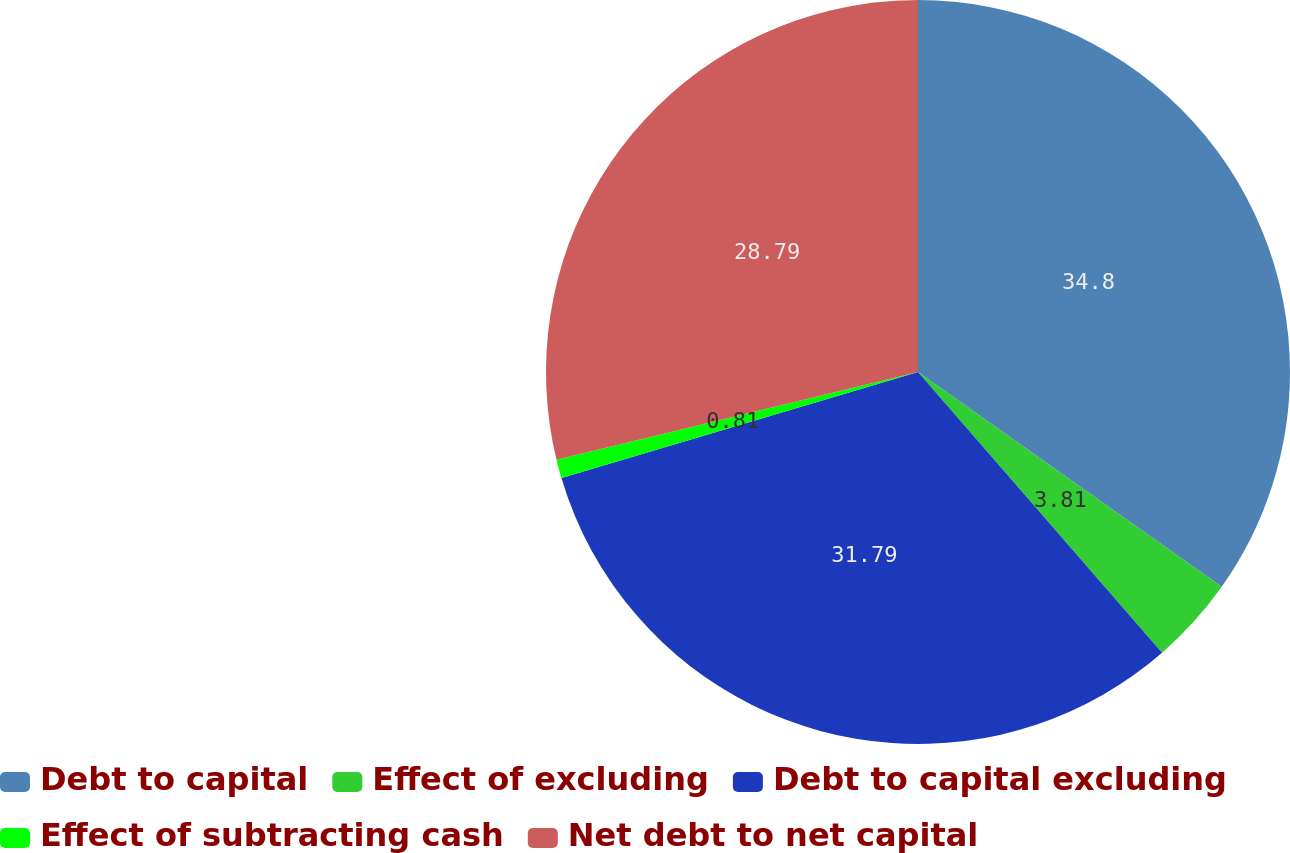Convert chart. <chart><loc_0><loc_0><loc_500><loc_500><pie_chart><fcel>Debt to capital<fcel>Effect of excluding<fcel>Debt to capital excluding<fcel>Effect of subtracting cash<fcel>Net debt to net capital<nl><fcel>34.8%<fcel>3.81%<fcel>31.79%<fcel>0.81%<fcel>28.79%<nl></chart> 